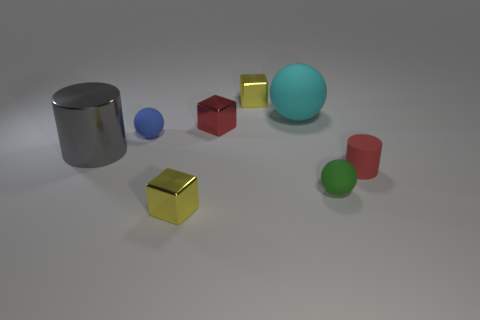Subtract all gray cubes. Subtract all green cylinders. How many cubes are left? 3 Subtract all blue blocks. How many yellow balls are left? 0 Add 7 blues. How many large things exist? 0 Subtract all tiny yellow metallic objects. Subtract all green things. How many objects are left? 5 Add 3 blue matte spheres. How many blue matte spheres are left? 4 Add 6 brown metallic objects. How many brown metallic objects exist? 6 Add 1 small red metal cylinders. How many objects exist? 9 Subtract all gray cylinders. How many cylinders are left? 1 Subtract all small yellow shiny cubes. How many cubes are left? 1 Subtract 0 gray blocks. How many objects are left? 8 